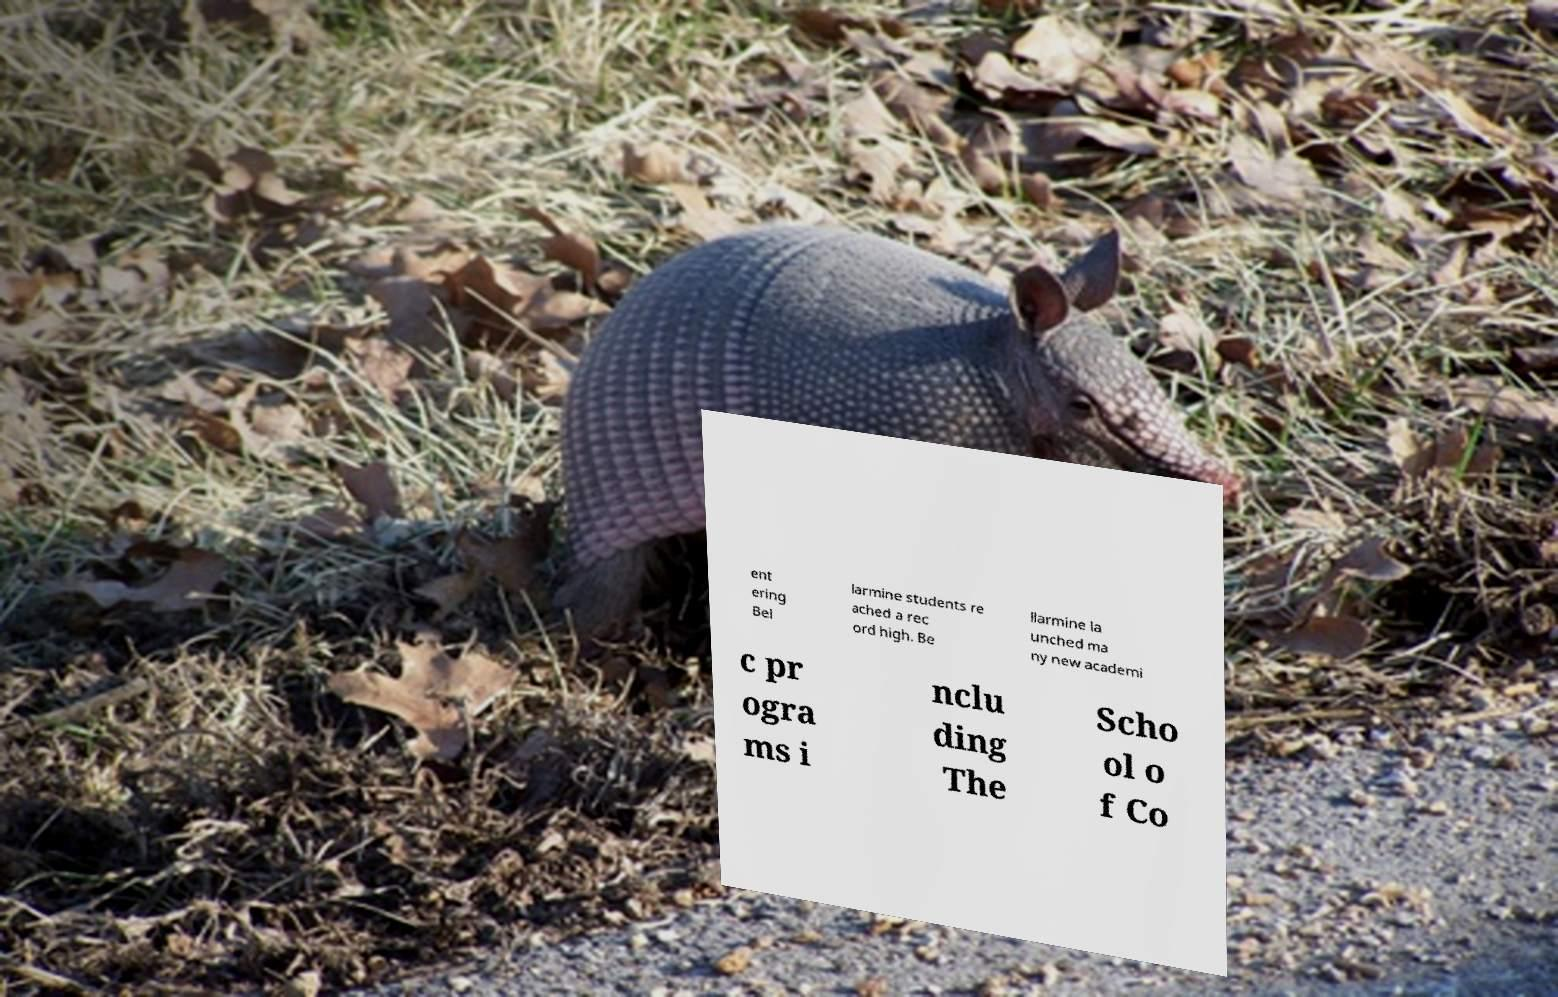I need the written content from this picture converted into text. Can you do that? ent ering Bel larmine students re ached a rec ord high. Be llarmine la unched ma ny new academi c pr ogra ms i nclu ding The Scho ol o f Co 